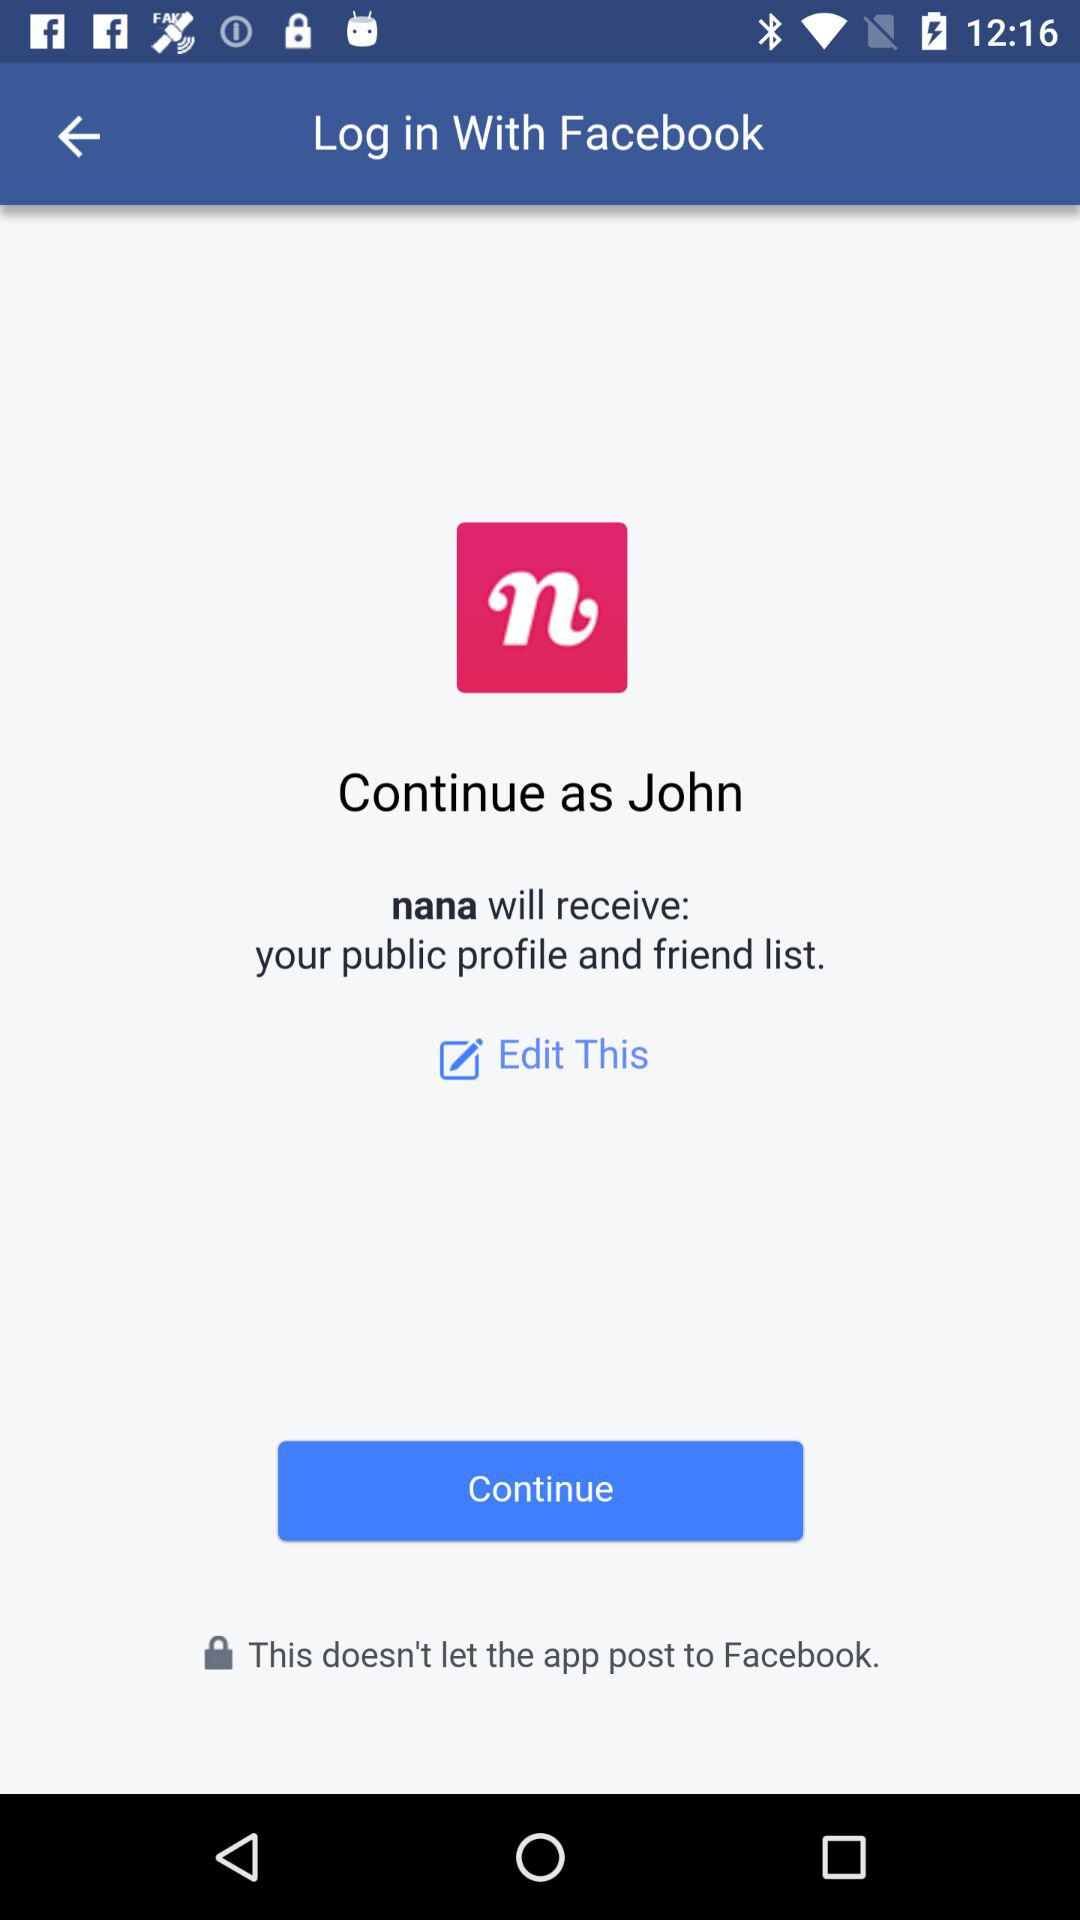What is the user name? The user name is John. 